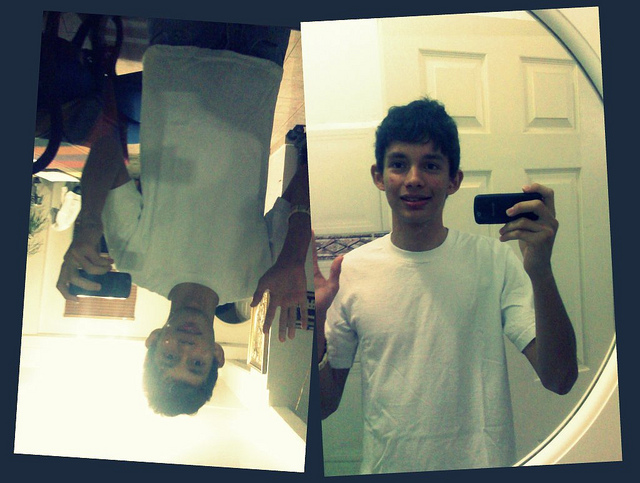Can you describe the general appearance of the person in the image? The image features a young individual with short, dark hair. The person is dressed casually in a plain white T-shirt and is holding a cellular phone. An interesting aspect of the photo shows the person's reflection captured in an upside-down orientation, likely in a mirror. Additionally, another portion of the image displays the person taking a selfie in a mirror, with the phone held in one hand. 